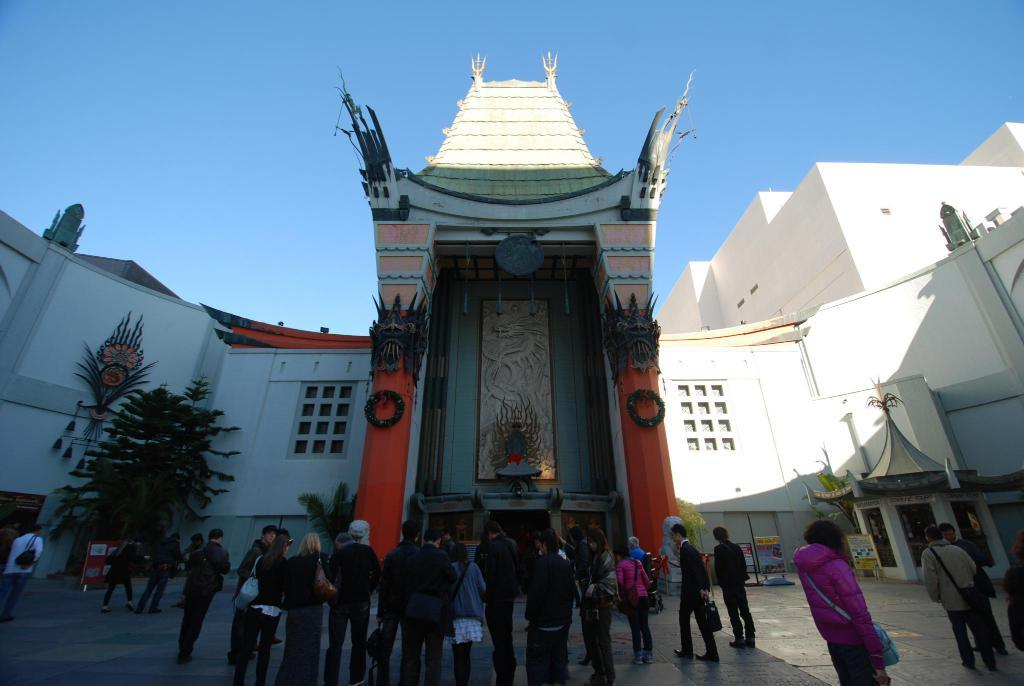What are the people in the image doing? The people in the image are standing on a path. What can be seen behind the people? There are trees behind the people. What else is visible in the background of the image? There are buildings and the sky visible in the background. What type of iron is being used by the people in the image? There is no iron present in the image; the people are standing on a path. How many oranges are visible in the image? There are no oranges present in the image. 